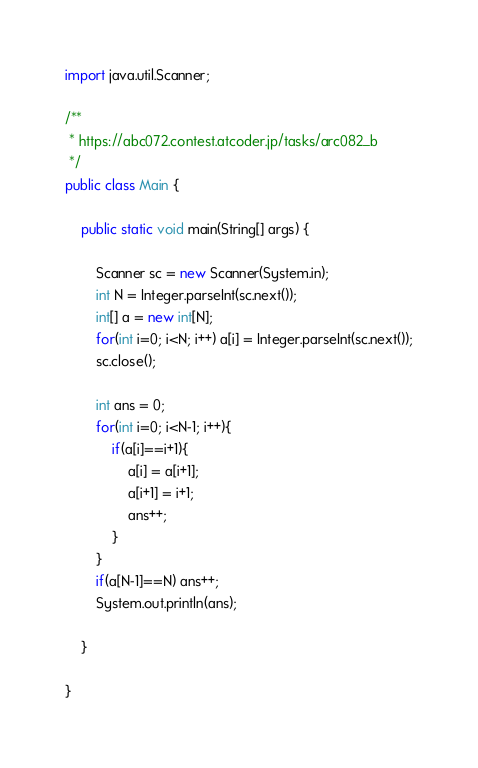<code> <loc_0><loc_0><loc_500><loc_500><_Java_>import java.util.Scanner;

/**
 * https://abc072.contest.atcoder.jp/tasks/arc082_b
 */
public class Main {

	public static void main(String[] args) {
		
		Scanner sc = new Scanner(System.in);
		int N = Integer.parseInt(sc.next());
		int[] a = new int[N];
		for(int i=0; i<N; i++) a[i] = Integer.parseInt(sc.next());
		sc.close();
		
		int ans = 0;
		for(int i=0; i<N-1; i++){
			if(a[i]==i+1){
				a[i] = a[i+1];
				a[i+1] = i+1;
				ans++;
			}
		}
		if(a[N-1]==N) ans++;
		System.out.println(ans);
		
	}

}</code> 